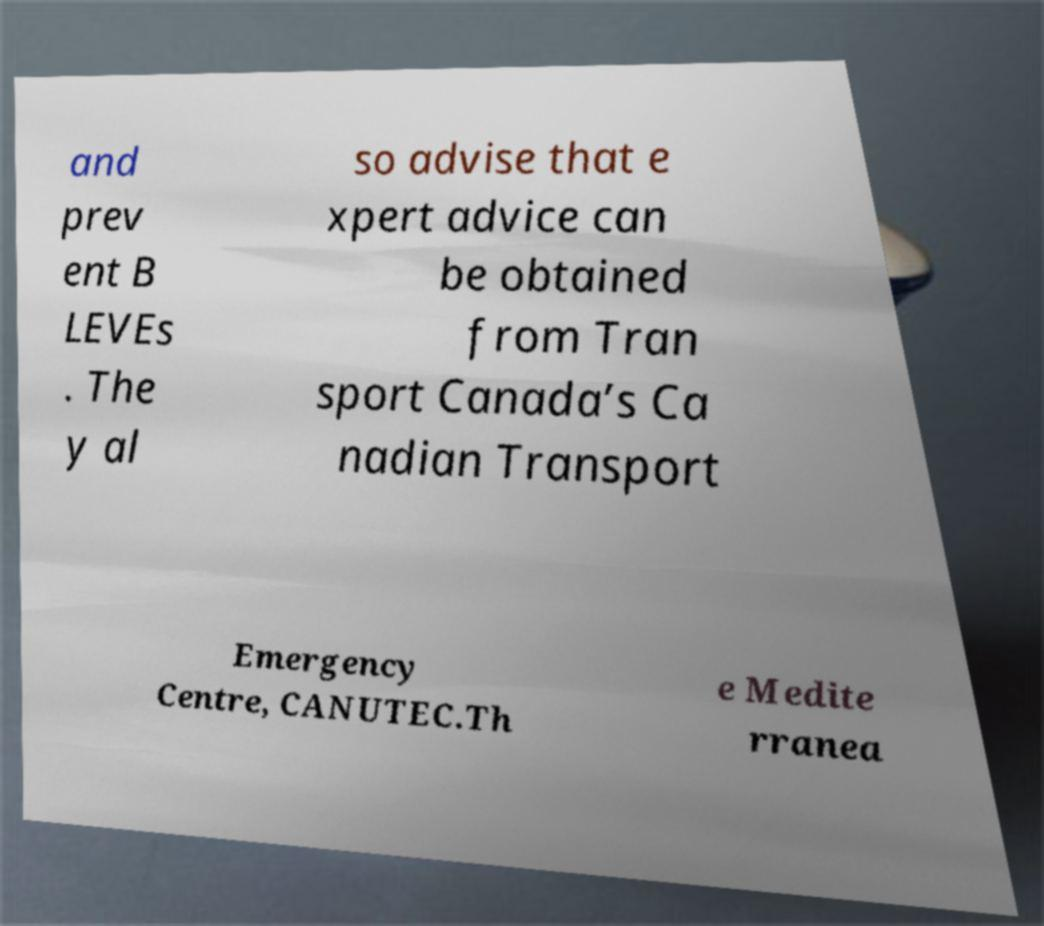Could you extract and type out the text from this image? and prev ent B LEVEs . The y al so advise that e xpert advice can be obtained from Tran sport Canada’s Ca nadian Transport Emergency Centre, CANUTEC.Th e Medite rranea 